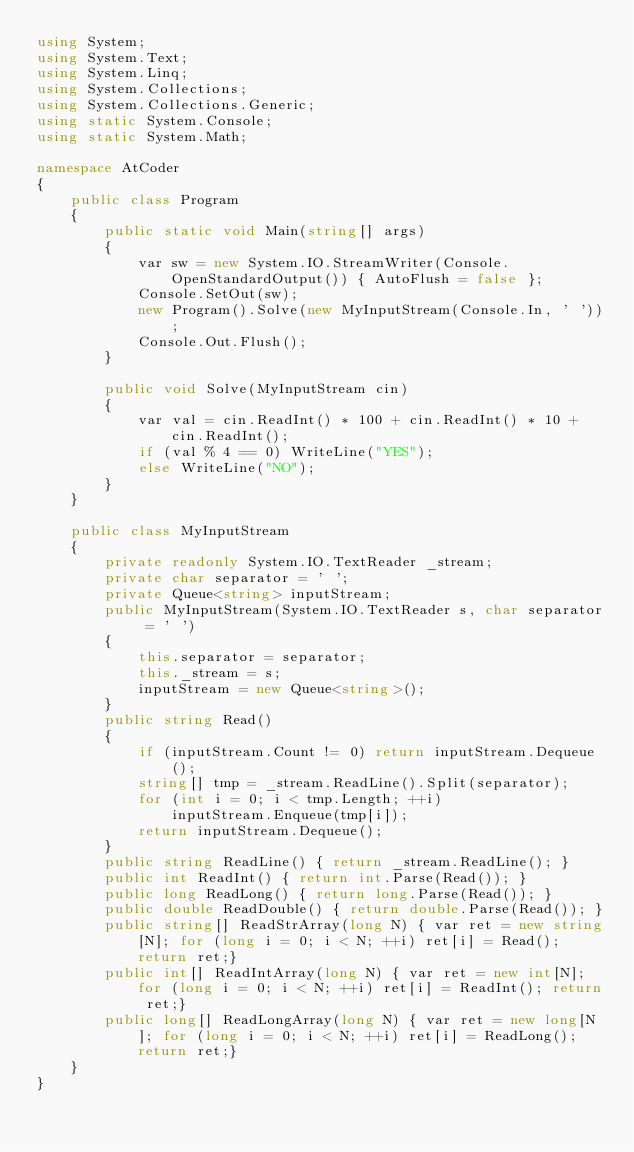Convert code to text. <code><loc_0><loc_0><loc_500><loc_500><_C#_>using System;
using System.Text;
using System.Linq;
using System.Collections;
using System.Collections.Generic;
using static System.Console;
using static System.Math;

namespace AtCoder
{
    public class Program
    {
        public static void Main(string[] args)
        {
            var sw = new System.IO.StreamWriter(Console.OpenStandardOutput()) { AutoFlush = false };
            Console.SetOut(sw);
            new Program().Solve(new MyInputStream(Console.In, ' '));
            Console.Out.Flush();
        }

        public void Solve(MyInputStream cin)
        {
            var val = cin.ReadInt() * 100 + cin.ReadInt() * 10 + cin.ReadInt();
            if (val % 4 == 0) WriteLine("YES");
            else WriteLine("NO");
        }
    }

    public class MyInputStream
    {
        private readonly System.IO.TextReader _stream;
        private char separator = ' ';
        private Queue<string> inputStream;
        public MyInputStream(System.IO.TextReader s, char separator = ' ')
        {
            this.separator = separator;
            this._stream = s;
            inputStream = new Queue<string>();
        }
        public string Read()
        {
            if (inputStream.Count != 0) return inputStream.Dequeue();
            string[] tmp = _stream.ReadLine().Split(separator);
            for (int i = 0; i < tmp.Length; ++i)
                inputStream.Enqueue(tmp[i]);
            return inputStream.Dequeue();
        }
        public string ReadLine() { return _stream.ReadLine(); }
        public int ReadInt() { return int.Parse(Read()); }
        public long ReadLong() { return long.Parse(Read()); }
        public double ReadDouble() { return double.Parse(Read()); }
        public string[] ReadStrArray(long N) { var ret = new string[N]; for (long i = 0; i < N; ++i) ret[i] = Read(); return ret;}
        public int[] ReadIntArray(long N) { var ret = new int[N]; for (long i = 0; i < N; ++i) ret[i] = ReadInt(); return ret;}
        public long[] ReadLongArray(long N) { var ret = new long[N]; for (long i = 0; i < N; ++i) ret[i] = ReadLong(); return ret;}
    }
}

</code> 